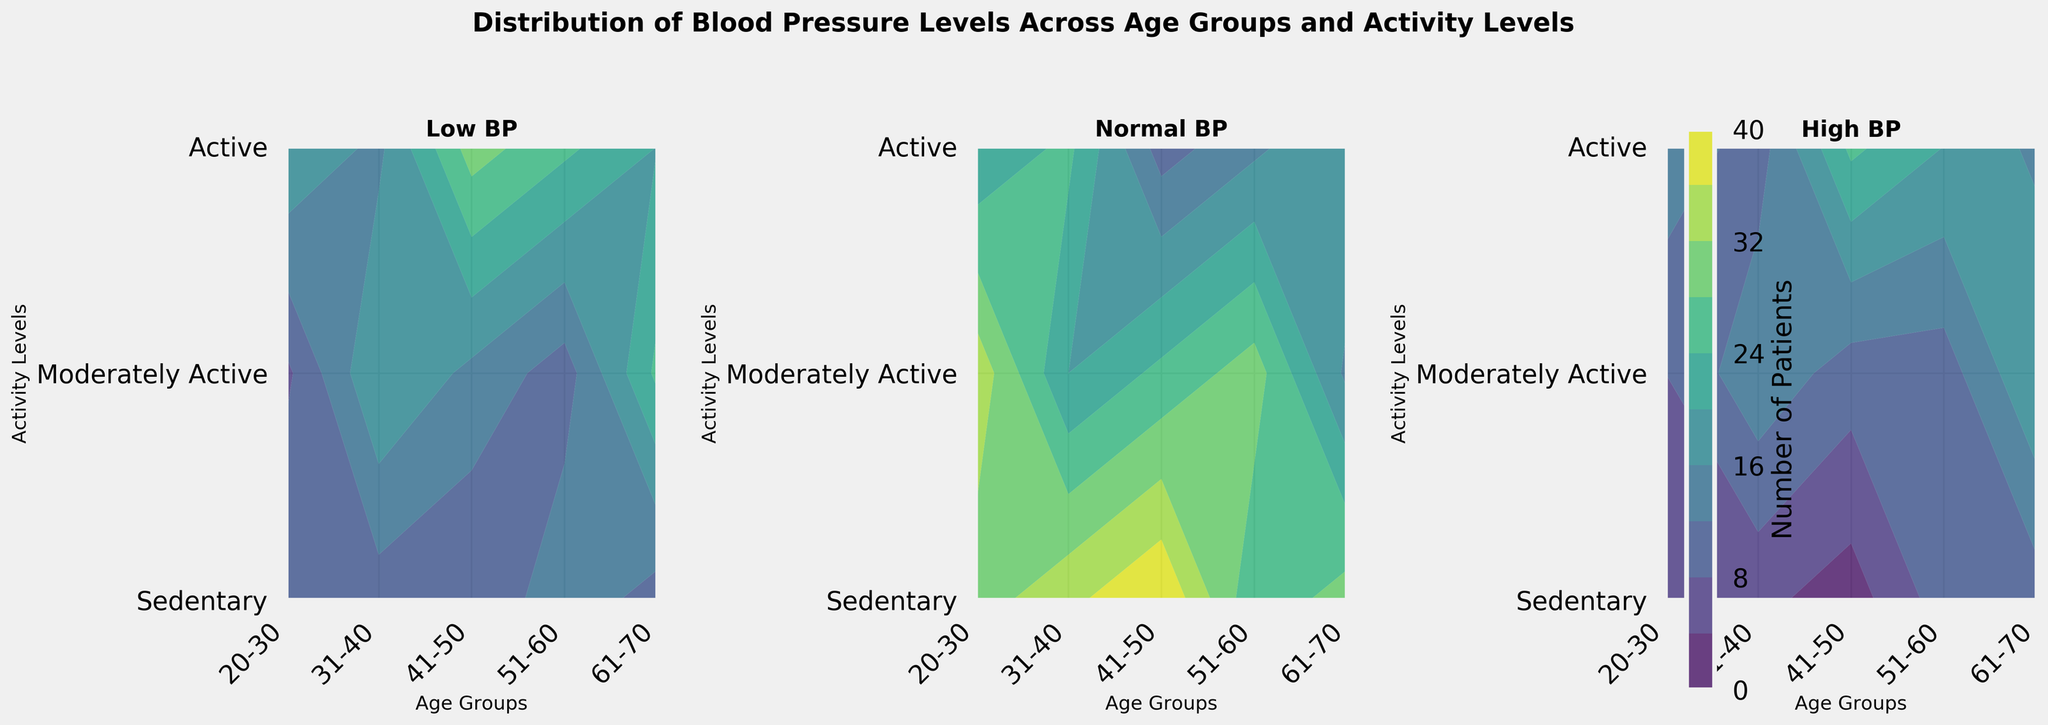What are the titles of each contour plot? The titles are written at the top of each subplot. The first subplot is titled "Low BP", the second one is "Normal BP", and the third one is "High BP".
Answer: Low BP, Normal BP, High BP Which age group has the highest number of patients with low blood pressure in the Active category? The "Active" category is on the y-axis, and the highest number of patients with low blood pressure in the Active category can be identified by comparing the contour colors in the "Low BP" plot. For the "Low BP" plot, the most intense color (representing the highest number) for the Active category is found in the 20-30 age group.
Answer: 20-30 How does the distribution of normal blood pressure differ across activity levels in the 31-40 age group? In the "Normal BP" plot, look at the contour colors along the x-axis position for the 31-40 age group and compare the colors across different y-axis positions for the activity levels (Sedentary, Moderately Active, Active). In the 31-40 age group, Sedentary has a lighter contour suggesting fewer patients, while Moderately Active and Active categories have darker contours indicating a higher number of patients.
Answer: More patients in Moderately Active and Active levels than Sedentary Which category appears to have the least variance in high blood pressure patients across different age groups? To determine the least variance, observe which category has the most consistent contour colors across the different age groups in the "High BP" contour plot. In this case, the "Active" category shows relatively consistent colors, indicating a more uniform distribution of high blood pressure patients.
Answer: Active For which age group and activity level combination is high blood pressure most prevalent? In the "High BP" contour plot, we identify the highest prevalence by locating the most intense color (darkest) among all age group and activity level combinations. The highest intensity is seen in the Sedentary category within the 61-70 age group, suggesting the peak prevalence of high blood pressure.
Answer: 61-70 Sedentary Which age group has more patients with normal blood pressure in the Moderately Active category? In the "Normal BP" contour plot, focus on the y-axis position for the Moderately Active category and compare the contour colors across different age groups on the x-axis. The most intense color for the Moderately Active category appears in the 20-30 and 31-40 age groups, indicating these groups have more patients.
Answer: 20-30 and 31-40 Is there a general trend observed in low blood pressure levels across age groups for Sedentary patients? Observe the "Low BP" contour plot for the Sedentary category on the y-axis and see if there is any pattern in contour intensity from left to right (across age groups). The contour colors become darker as age increases, indicating that more older patients in sedentary groups have low blood pressure.
Answer: Increases with age How does the activity level impact high blood pressure in the 51-60 age group? In the "High BP" plot, focus on the x-axis position for the 51-60 age group and compare contour colors along the y-axis for different activity levels. Sedentary shows the most intense color (darkest), while Active has the lightest contour, suggesting that higher activity levels are associated with fewer high blood pressure patients.
Answer: Higher activity levels reduce high blood pressure What trend can be observed in normal blood pressure levels moving from younger to older age groups in the Sedentary category? Look at the "Normal BP" plot for the Sedentary category along the y-axis and observe how the contour colors change from left to right (younger to older age groups). The contours get lighter, indicating a decreasing trend in normal blood pressure levels as age increases.
Answer: Decreases with age 